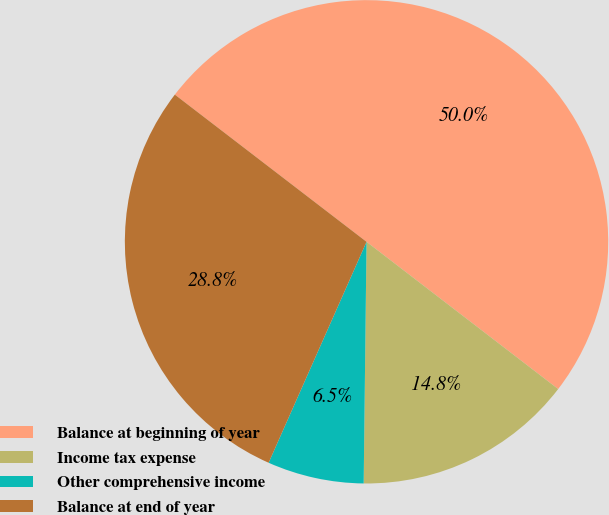Convert chart to OTSL. <chart><loc_0><loc_0><loc_500><loc_500><pie_chart><fcel>Balance at beginning of year<fcel>Income tax expense<fcel>Other comprehensive income<fcel>Balance at end of year<nl><fcel>50.0%<fcel>14.76%<fcel>6.45%<fcel>28.78%<nl></chart> 